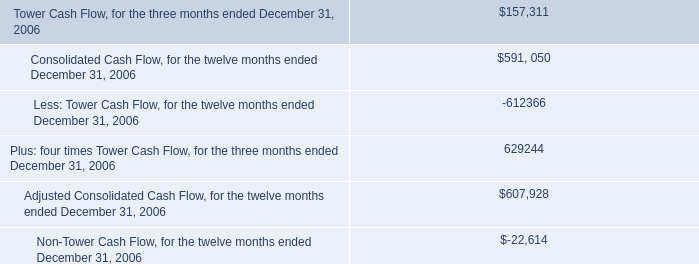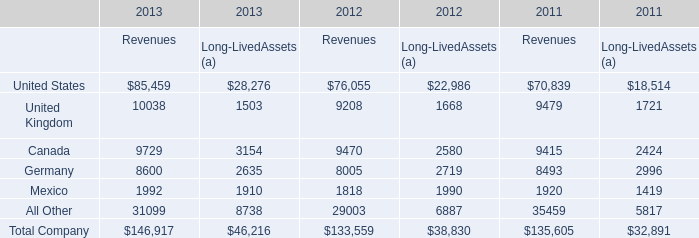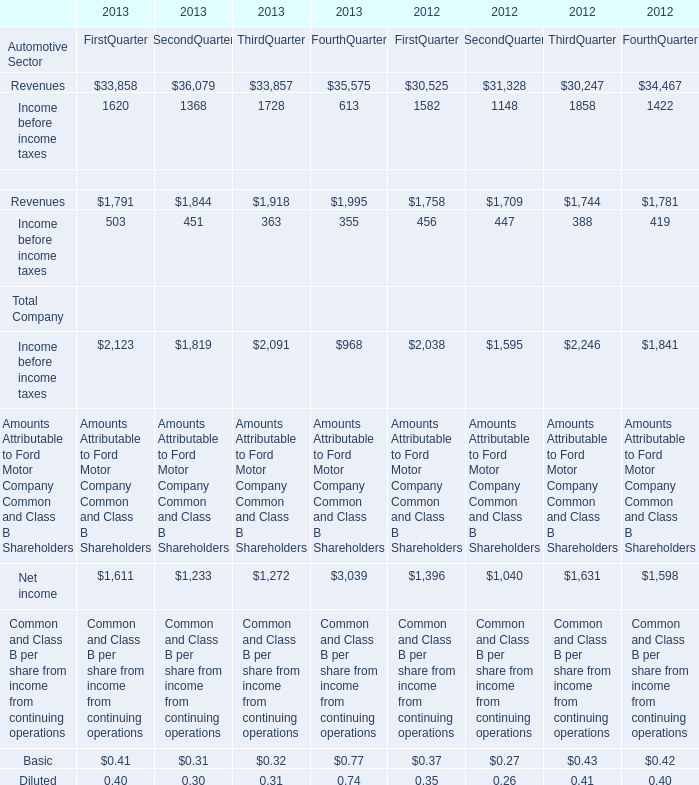What is the percentage of all Revenues of Automotive Sector that are positive to the total amount, in 2013? (in %) 
Computations: ((((33858 + 36079) + 33857) + 35575) / (((33858 + 36079) + 33857) + 35575))
Answer: 1.0. 